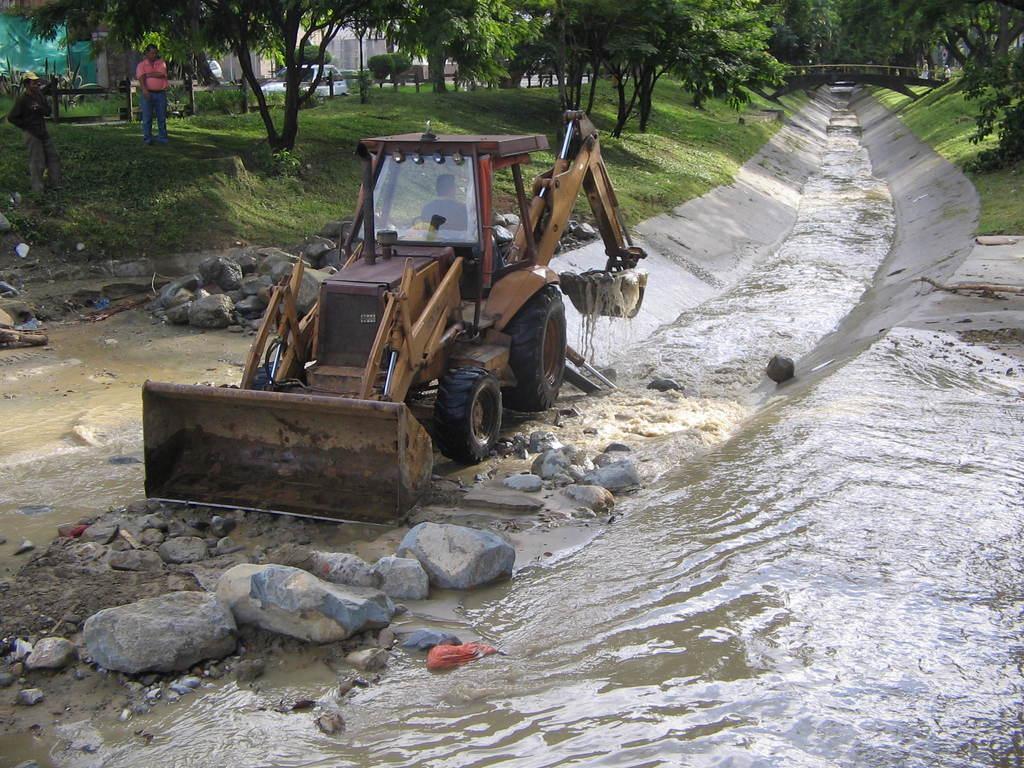Please provide a concise description of this image. In this image we can see the bulldozer, here we can see the stones, water, canal, two persons standing on the grass, we can see trees, a vehicle on the road and we can see the bridge in the background. 